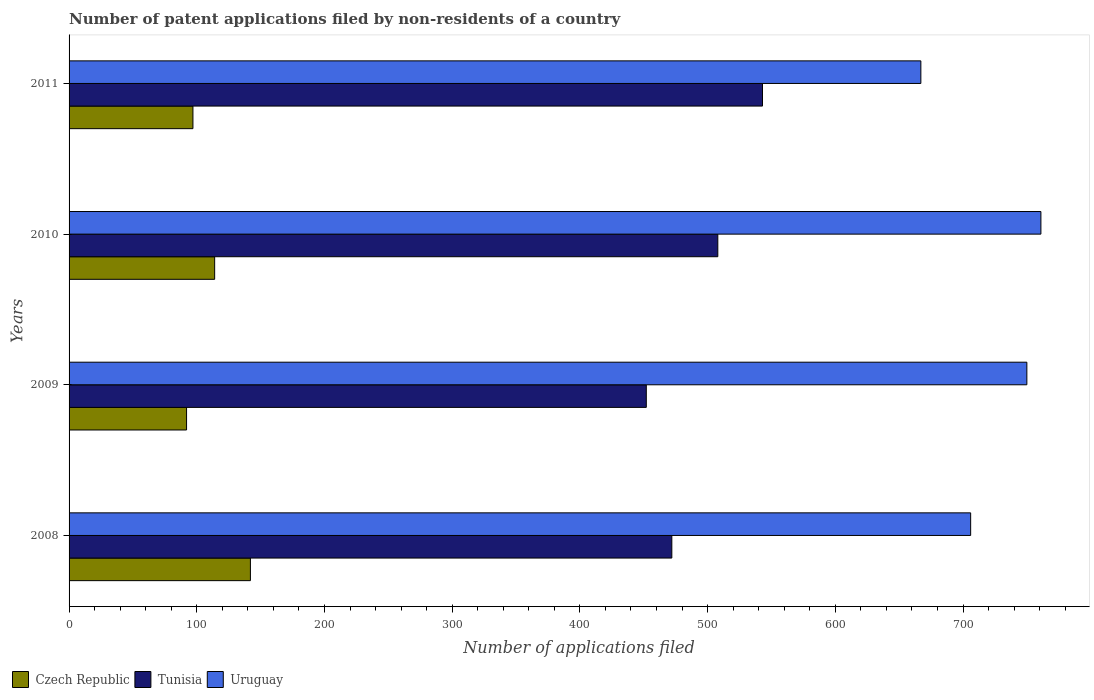How many bars are there on the 4th tick from the bottom?
Your answer should be compact. 3. What is the label of the 3rd group of bars from the top?
Provide a succinct answer. 2009. In how many cases, is the number of bars for a given year not equal to the number of legend labels?
Offer a terse response. 0. What is the number of applications filed in Tunisia in 2011?
Offer a terse response. 543. Across all years, what is the maximum number of applications filed in Czech Republic?
Offer a very short reply. 142. Across all years, what is the minimum number of applications filed in Czech Republic?
Ensure brevity in your answer.  92. What is the total number of applications filed in Tunisia in the graph?
Provide a succinct answer. 1975. What is the difference between the number of applications filed in Tunisia in 2009 and that in 2011?
Make the answer very short. -91. What is the difference between the number of applications filed in Czech Republic in 2009 and the number of applications filed in Uruguay in 2008?
Provide a short and direct response. -614. What is the average number of applications filed in Tunisia per year?
Your answer should be very brief. 493.75. In the year 2008, what is the difference between the number of applications filed in Tunisia and number of applications filed in Uruguay?
Your answer should be very brief. -234. What is the ratio of the number of applications filed in Uruguay in 2010 to that in 2011?
Give a very brief answer. 1.14. Is the difference between the number of applications filed in Tunisia in 2010 and 2011 greater than the difference between the number of applications filed in Uruguay in 2010 and 2011?
Your answer should be very brief. No. What is the difference between the highest and the second highest number of applications filed in Uruguay?
Offer a very short reply. 11. What is the difference between the highest and the lowest number of applications filed in Czech Republic?
Make the answer very short. 50. In how many years, is the number of applications filed in Tunisia greater than the average number of applications filed in Tunisia taken over all years?
Your answer should be compact. 2. Is the sum of the number of applications filed in Tunisia in 2010 and 2011 greater than the maximum number of applications filed in Czech Republic across all years?
Offer a terse response. Yes. What does the 2nd bar from the top in 2008 represents?
Offer a very short reply. Tunisia. What does the 1st bar from the bottom in 2009 represents?
Provide a short and direct response. Czech Republic. Is it the case that in every year, the sum of the number of applications filed in Uruguay and number of applications filed in Czech Republic is greater than the number of applications filed in Tunisia?
Give a very brief answer. Yes. What is the difference between two consecutive major ticks on the X-axis?
Your response must be concise. 100. Are the values on the major ticks of X-axis written in scientific E-notation?
Your answer should be compact. No. Does the graph contain any zero values?
Your answer should be compact. No. Does the graph contain grids?
Give a very brief answer. No. How many legend labels are there?
Your answer should be very brief. 3. How are the legend labels stacked?
Make the answer very short. Horizontal. What is the title of the graph?
Offer a terse response. Number of patent applications filed by non-residents of a country. Does "Trinidad and Tobago" appear as one of the legend labels in the graph?
Your answer should be very brief. No. What is the label or title of the X-axis?
Provide a succinct answer. Number of applications filed. What is the Number of applications filed of Czech Republic in 2008?
Your answer should be compact. 142. What is the Number of applications filed in Tunisia in 2008?
Provide a succinct answer. 472. What is the Number of applications filed in Uruguay in 2008?
Provide a succinct answer. 706. What is the Number of applications filed in Czech Republic in 2009?
Make the answer very short. 92. What is the Number of applications filed in Tunisia in 2009?
Offer a very short reply. 452. What is the Number of applications filed of Uruguay in 2009?
Make the answer very short. 750. What is the Number of applications filed in Czech Republic in 2010?
Your answer should be very brief. 114. What is the Number of applications filed of Tunisia in 2010?
Your answer should be very brief. 508. What is the Number of applications filed in Uruguay in 2010?
Give a very brief answer. 761. What is the Number of applications filed of Czech Republic in 2011?
Your answer should be very brief. 97. What is the Number of applications filed of Tunisia in 2011?
Your answer should be compact. 543. What is the Number of applications filed in Uruguay in 2011?
Your answer should be very brief. 667. Across all years, what is the maximum Number of applications filed of Czech Republic?
Provide a short and direct response. 142. Across all years, what is the maximum Number of applications filed in Tunisia?
Offer a very short reply. 543. Across all years, what is the maximum Number of applications filed in Uruguay?
Offer a very short reply. 761. Across all years, what is the minimum Number of applications filed in Czech Republic?
Ensure brevity in your answer.  92. Across all years, what is the minimum Number of applications filed of Tunisia?
Make the answer very short. 452. Across all years, what is the minimum Number of applications filed in Uruguay?
Your answer should be very brief. 667. What is the total Number of applications filed of Czech Republic in the graph?
Your answer should be compact. 445. What is the total Number of applications filed in Tunisia in the graph?
Give a very brief answer. 1975. What is the total Number of applications filed of Uruguay in the graph?
Offer a very short reply. 2884. What is the difference between the Number of applications filed of Czech Republic in 2008 and that in 2009?
Ensure brevity in your answer.  50. What is the difference between the Number of applications filed in Uruguay in 2008 and that in 2009?
Make the answer very short. -44. What is the difference between the Number of applications filed of Czech Republic in 2008 and that in 2010?
Offer a terse response. 28. What is the difference between the Number of applications filed of Tunisia in 2008 and that in 2010?
Provide a succinct answer. -36. What is the difference between the Number of applications filed in Uruguay in 2008 and that in 2010?
Give a very brief answer. -55. What is the difference between the Number of applications filed in Tunisia in 2008 and that in 2011?
Your answer should be compact. -71. What is the difference between the Number of applications filed in Uruguay in 2008 and that in 2011?
Give a very brief answer. 39. What is the difference between the Number of applications filed in Tunisia in 2009 and that in 2010?
Your answer should be compact. -56. What is the difference between the Number of applications filed of Tunisia in 2009 and that in 2011?
Offer a very short reply. -91. What is the difference between the Number of applications filed of Tunisia in 2010 and that in 2011?
Your answer should be compact. -35. What is the difference between the Number of applications filed of Uruguay in 2010 and that in 2011?
Offer a very short reply. 94. What is the difference between the Number of applications filed of Czech Republic in 2008 and the Number of applications filed of Tunisia in 2009?
Offer a terse response. -310. What is the difference between the Number of applications filed in Czech Republic in 2008 and the Number of applications filed in Uruguay in 2009?
Your answer should be compact. -608. What is the difference between the Number of applications filed in Tunisia in 2008 and the Number of applications filed in Uruguay in 2009?
Offer a terse response. -278. What is the difference between the Number of applications filed of Czech Republic in 2008 and the Number of applications filed of Tunisia in 2010?
Provide a short and direct response. -366. What is the difference between the Number of applications filed in Czech Republic in 2008 and the Number of applications filed in Uruguay in 2010?
Offer a terse response. -619. What is the difference between the Number of applications filed in Tunisia in 2008 and the Number of applications filed in Uruguay in 2010?
Offer a terse response. -289. What is the difference between the Number of applications filed of Czech Republic in 2008 and the Number of applications filed of Tunisia in 2011?
Offer a terse response. -401. What is the difference between the Number of applications filed in Czech Republic in 2008 and the Number of applications filed in Uruguay in 2011?
Keep it short and to the point. -525. What is the difference between the Number of applications filed of Tunisia in 2008 and the Number of applications filed of Uruguay in 2011?
Offer a very short reply. -195. What is the difference between the Number of applications filed of Czech Republic in 2009 and the Number of applications filed of Tunisia in 2010?
Offer a very short reply. -416. What is the difference between the Number of applications filed in Czech Republic in 2009 and the Number of applications filed in Uruguay in 2010?
Offer a terse response. -669. What is the difference between the Number of applications filed in Tunisia in 2009 and the Number of applications filed in Uruguay in 2010?
Keep it short and to the point. -309. What is the difference between the Number of applications filed of Czech Republic in 2009 and the Number of applications filed of Tunisia in 2011?
Your answer should be very brief. -451. What is the difference between the Number of applications filed in Czech Republic in 2009 and the Number of applications filed in Uruguay in 2011?
Provide a short and direct response. -575. What is the difference between the Number of applications filed of Tunisia in 2009 and the Number of applications filed of Uruguay in 2011?
Make the answer very short. -215. What is the difference between the Number of applications filed of Czech Republic in 2010 and the Number of applications filed of Tunisia in 2011?
Offer a very short reply. -429. What is the difference between the Number of applications filed of Czech Republic in 2010 and the Number of applications filed of Uruguay in 2011?
Your answer should be very brief. -553. What is the difference between the Number of applications filed of Tunisia in 2010 and the Number of applications filed of Uruguay in 2011?
Offer a very short reply. -159. What is the average Number of applications filed of Czech Republic per year?
Keep it short and to the point. 111.25. What is the average Number of applications filed in Tunisia per year?
Provide a succinct answer. 493.75. What is the average Number of applications filed in Uruguay per year?
Your answer should be very brief. 721. In the year 2008, what is the difference between the Number of applications filed of Czech Republic and Number of applications filed of Tunisia?
Ensure brevity in your answer.  -330. In the year 2008, what is the difference between the Number of applications filed in Czech Republic and Number of applications filed in Uruguay?
Your answer should be very brief. -564. In the year 2008, what is the difference between the Number of applications filed of Tunisia and Number of applications filed of Uruguay?
Offer a terse response. -234. In the year 2009, what is the difference between the Number of applications filed of Czech Republic and Number of applications filed of Tunisia?
Ensure brevity in your answer.  -360. In the year 2009, what is the difference between the Number of applications filed of Czech Republic and Number of applications filed of Uruguay?
Offer a very short reply. -658. In the year 2009, what is the difference between the Number of applications filed of Tunisia and Number of applications filed of Uruguay?
Give a very brief answer. -298. In the year 2010, what is the difference between the Number of applications filed in Czech Republic and Number of applications filed in Tunisia?
Ensure brevity in your answer.  -394. In the year 2010, what is the difference between the Number of applications filed in Czech Republic and Number of applications filed in Uruguay?
Your answer should be very brief. -647. In the year 2010, what is the difference between the Number of applications filed in Tunisia and Number of applications filed in Uruguay?
Keep it short and to the point. -253. In the year 2011, what is the difference between the Number of applications filed in Czech Republic and Number of applications filed in Tunisia?
Offer a very short reply. -446. In the year 2011, what is the difference between the Number of applications filed of Czech Republic and Number of applications filed of Uruguay?
Provide a short and direct response. -570. In the year 2011, what is the difference between the Number of applications filed in Tunisia and Number of applications filed in Uruguay?
Your answer should be very brief. -124. What is the ratio of the Number of applications filed of Czech Republic in 2008 to that in 2009?
Your response must be concise. 1.54. What is the ratio of the Number of applications filed of Tunisia in 2008 to that in 2009?
Your answer should be compact. 1.04. What is the ratio of the Number of applications filed of Uruguay in 2008 to that in 2009?
Give a very brief answer. 0.94. What is the ratio of the Number of applications filed of Czech Republic in 2008 to that in 2010?
Your response must be concise. 1.25. What is the ratio of the Number of applications filed in Tunisia in 2008 to that in 2010?
Your answer should be compact. 0.93. What is the ratio of the Number of applications filed in Uruguay in 2008 to that in 2010?
Your answer should be very brief. 0.93. What is the ratio of the Number of applications filed of Czech Republic in 2008 to that in 2011?
Provide a succinct answer. 1.46. What is the ratio of the Number of applications filed in Tunisia in 2008 to that in 2011?
Provide a succinct answer. 0.87. What is the ratio of the Number of applications filed in Uruguay in 2008 to that in 2011?
Ensure brevity in your answer.  1.06. What is the ratio of the Number of applications filed in Czech Republic in 2009 to that in 2010?
Make the answer very short. 0.81. What is the ratio of the Number of applications filed in Tunisia in 2009 to that in 2010?
Offer a very short reply. 0.89. What is the ratio of the Number of applications filed of Uruguay in 2009 to that in 2010?
Give a very brief answer. 0.99. What is the ratio of the Number of applications filed in Czech Republic in 2009 to that in 2011?
Provide a succinct answer. 0.95. What is the ratio of the Number of applications filed of Tunisia in 2009 to that in 2011?
Your answer should be very brief. 0.83. What is the ratio of the Number of applications filed of Uruguay in 2009 to that in 2011?
Provide a succinct answer. 1.12. What is the ratio of the Number of applications filed in Czech Republic in 2010 to that in 2011?
Provide a short and direct response. 1.18. What is the ratio of the Number of applications filed of Tunisia in 2010 to that in 2011?
Your answer should be compact. 0.94. What is the ratio of the Number of applications filed in Uruguay in 2010 to that in 2011?
Keep it short and to the point. 1.14. What is the difference between the highest and the lowest Number of applications filed in Czech Republic?
Offer a terse response. 50. What is the difference between the highest and the lowest Number of applications filed of Tunisia?
Your answer should be very brief. 91. What is the difference between the highest and the lowest Number of applications filed of Uruguay?
Keep it short and to the point. 94. 